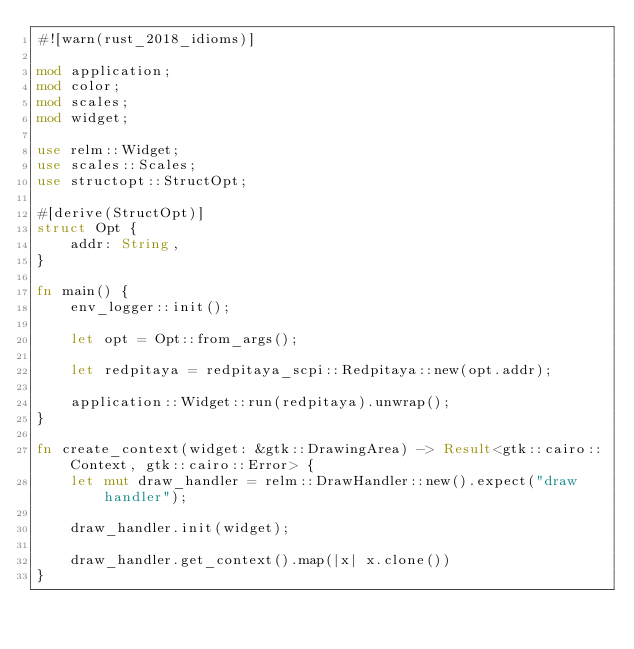Convert code to text. <code><loc_0><loc_0><loc_500><loc_500><_Rust_>#![warn(rust_2018_idioms)]

mod application;
mod color;
mod scales;
mod widget;

use relm::Widget;
use scales::Scales;
use structopt::StructOpt;

#[derive(StructOpt)]
struct Opt {
    addr: String,
}

fn main() {
    env_logger::init();

    let opt = Opt::from_args();

    let redpitaya = redpitaya_scpi::Redpitaya::new(opt.addr);

    application::Widget::run(redpitaya).unwrap();
}

fn create_context(widget: &gtk::DrawingArea) -> Result<gtk::cairo::Context, gtk::cairo::Error> {
    let mut draw_handler = relm::DrawHandler::new().expect("draw handler");

    draw_handler.init(widget);

    draw_handler.get_context().map(|x| x.clone())
}
</code> 